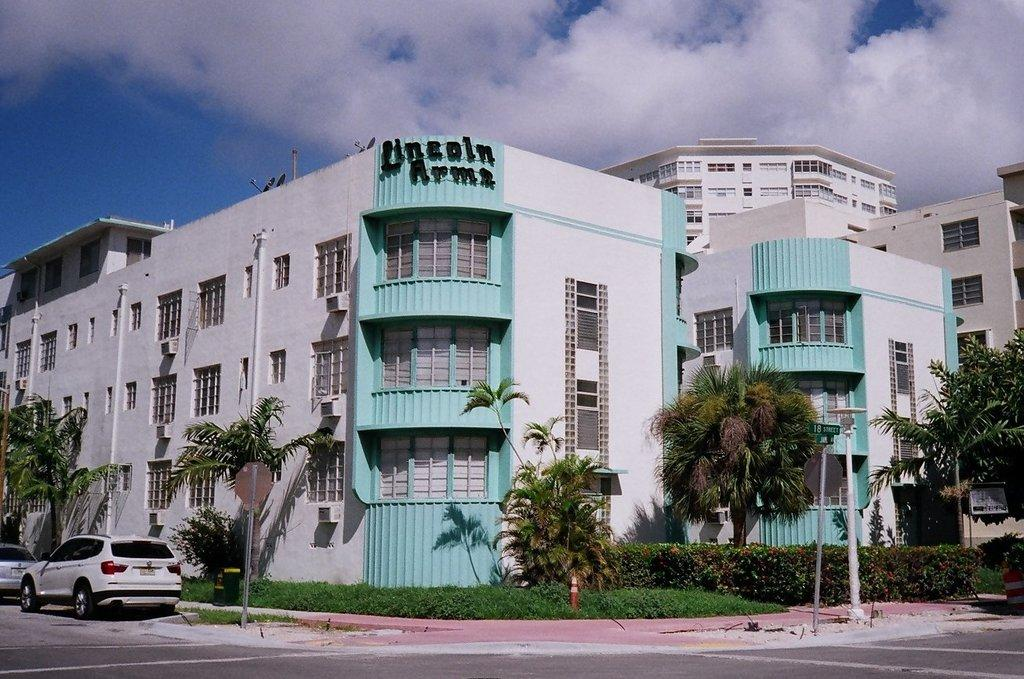What type of natural elements can be seen in the image? There are trees and plants in the image. What man-made structures are visible in the image? There are poles, vehicles, buildings, and windows in the image. What is visible in the sky in the image? There are clouds in the sky. Can you tell me how many times the word "help" is mentioned in the image? The word "help" is not mentioned in the image, as it is a visual medium. Is the person's dad visible in the image? There is no person or dad present in the image; it features trees, plants, poles, vehicles, buildings, windows, and clouds. 